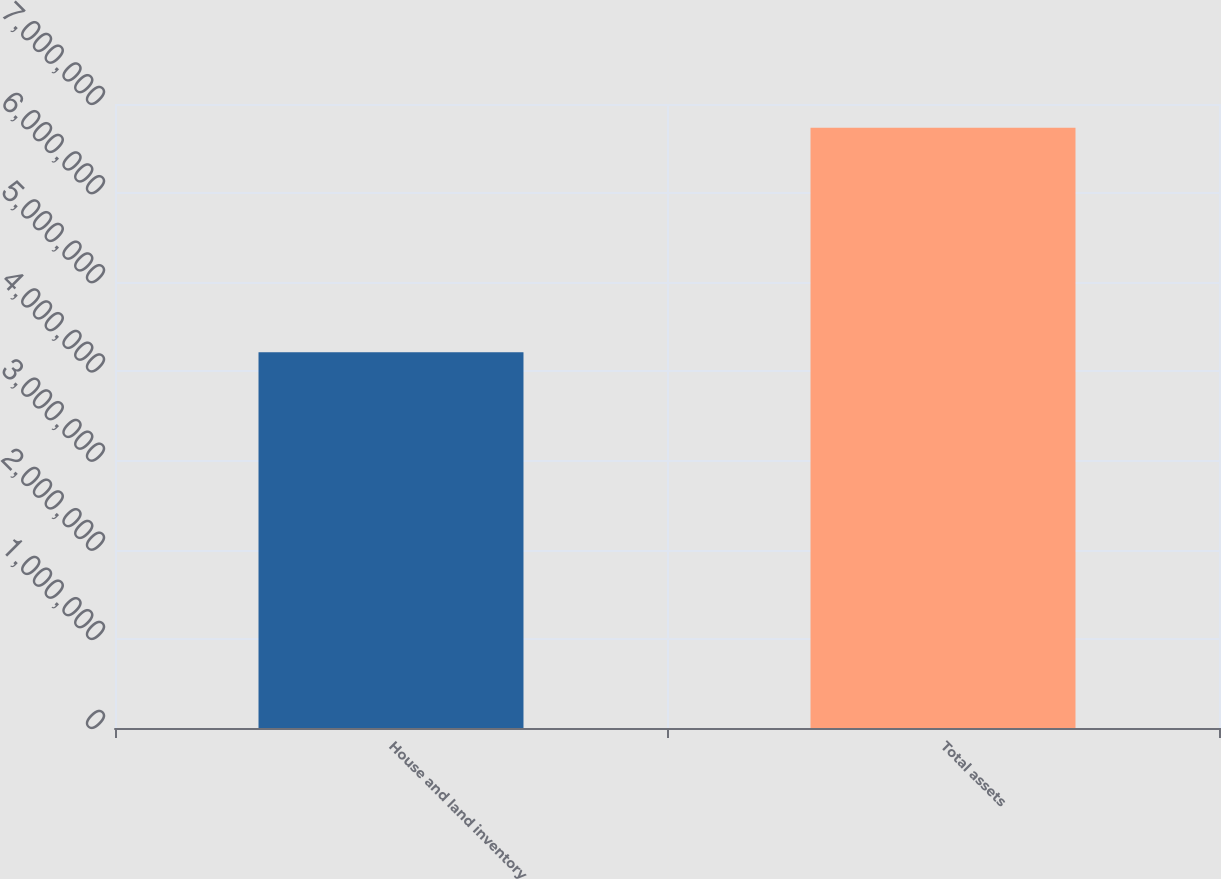Convert chart. <chart><loc_0><loc_0><loc_500><loc_500><bar_chart><fcel>House and land inventory<fcel>Total assets<nl><fcel>4.21405e+06<fcel>6.73441e+06<nl></chart> 